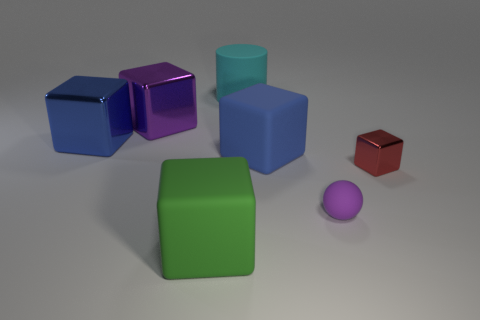Do the large metallic cube that is behind the blue metal block and the tiny rubber ball have the same color?
Your response must be concise. Yes. There is a block that is in front of the blue rubber object and on the right side of the big cyan cylinder; what material is it made of?
Your response must be concise. Metal. What shape is the big shiny thing that is the same color as the sphere?
Offer a very short reply. Cube. What is the size of the purple object that is made of the same material as the big green block?
Keep it short and to the point. Small. Is the size of the matte sphere the same as the red metal object?
Offer a very short reply. Yes. Is there a large rubber ball?
Your answer should be very brief. No. There is a shiny block that is the same color as the rubber ball; what is its size?
Your answer should be compact. Large. What is the size of the blue thing that is right of the large rubber thing that is behind the big metallic object on the left side of the purple shiny cube?
Make the answer very short. Large. How many green things have the same material as the sphere?
Keep it short and to the point. 1. What number of cyan rubber things have the same size as the green cube?
Provide a succinct answer. 1. 